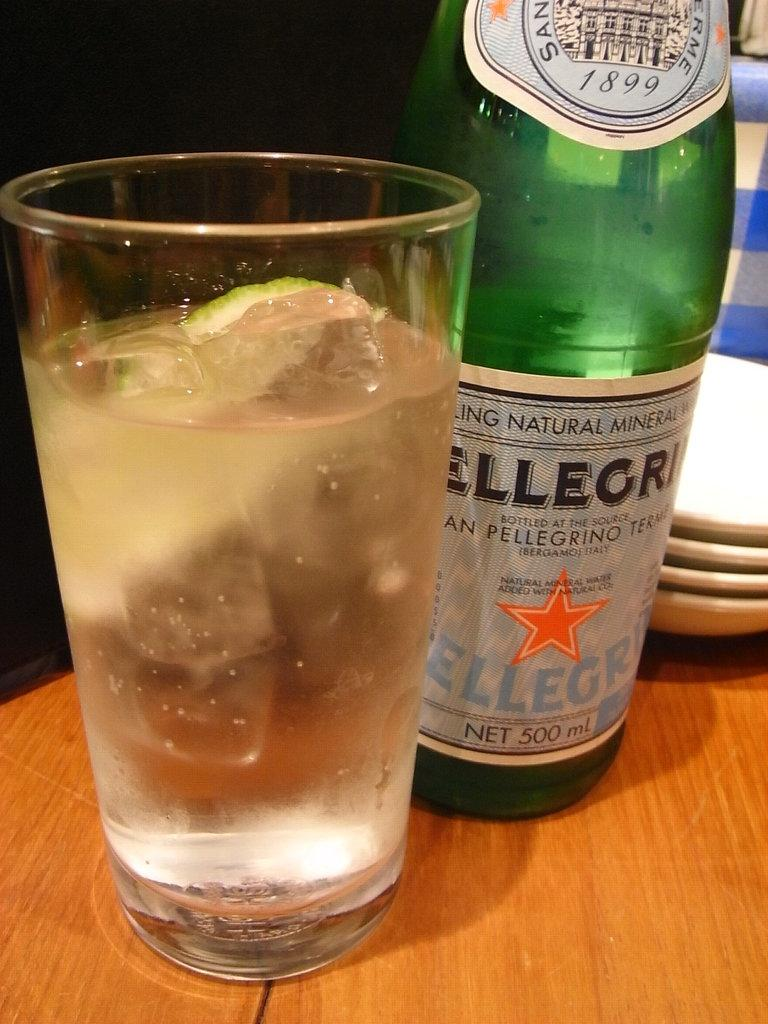<image>
Create a compact narrative representing the image presented. a bottle that has the words pellegrino on the front 